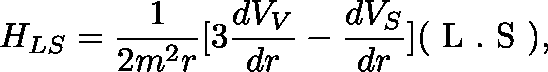Convert formula to latex. <formula><loc_0><loc_0><loc_500><loc_500>H _ { L S } = \frac { 1 } { 2 m ^ { 2 } r } [ 3 \frac { d V _ { V } } { d r } - \frac { d V _ { S } } { d r } ] ( \boldmath L . \boldmath S ) ,</formula> 